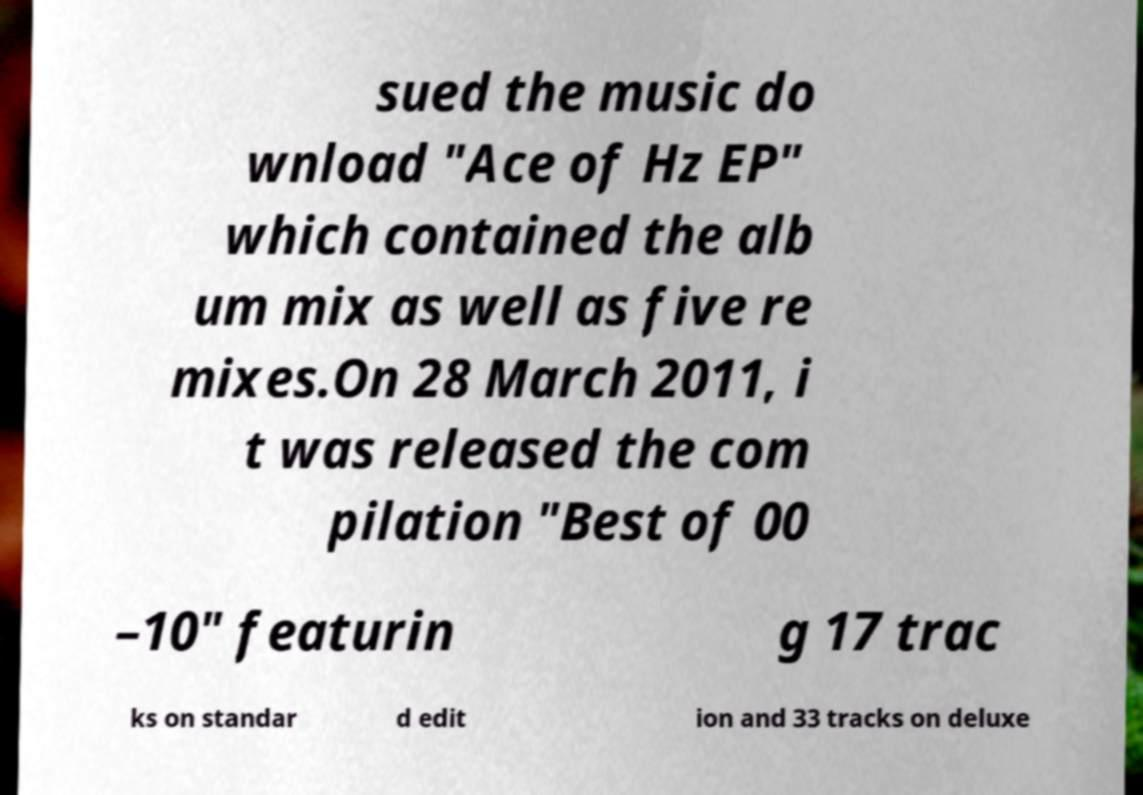There's text embedded in this image that I need extracted. Can you transcribe it verbatim? sued the music do wnload "Ace of Hz EP" which contained the alb um mix as well as five re mixes.On 28 March 2011, i t was released the com pilation "Best of 00 –10" featurin g 17 trac ks on standar d edit ion and 33 tracks on deluxe 